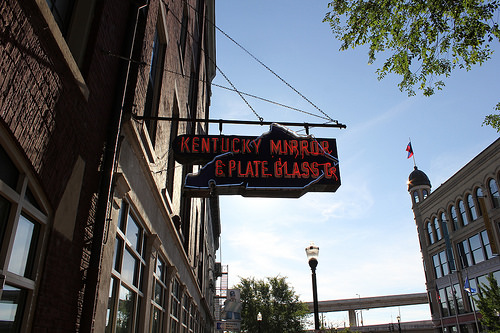<image>
Is the sign in front of the sky? Yes. The sign is positioned in front of the sky, appearing closer to the camera viewpoint. 